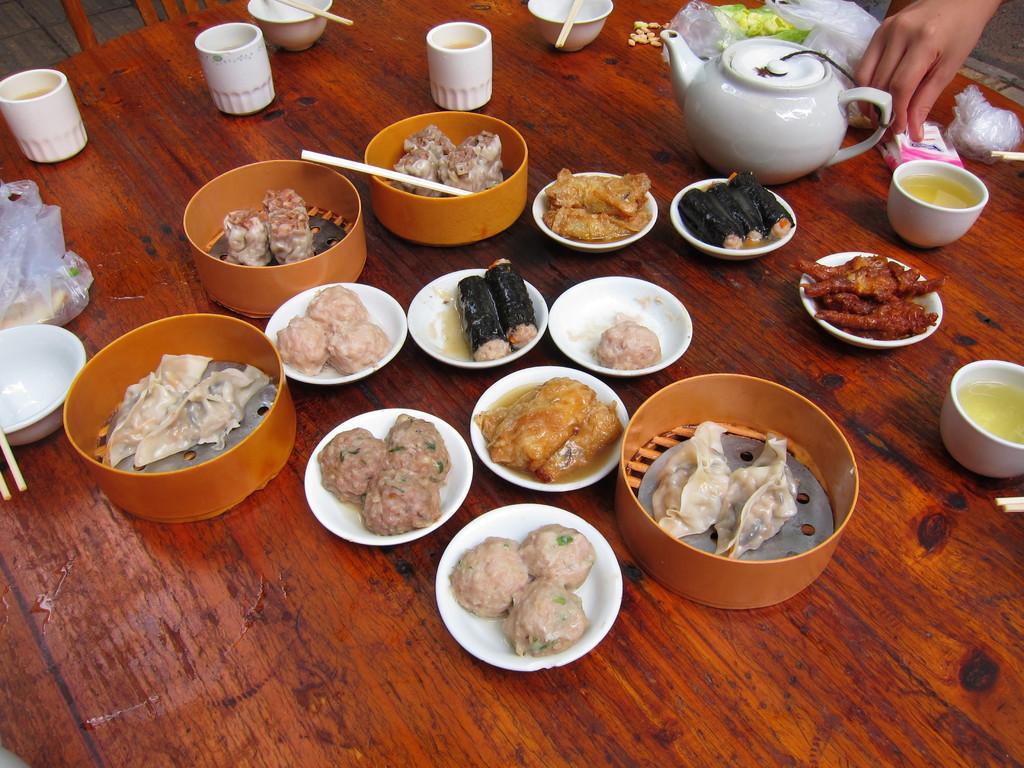Could you give a brief overview of what you see in this image? In this image we can see a table. On the table there are different kinds of dishes placed in bowls, chopsticks, kettle, vegetables and polythene covers. 